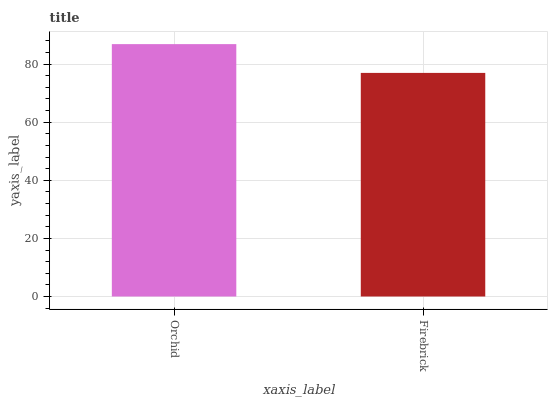Is Firebrick the minimum?
Answer yes or no. Yes. Is Orchid the maximum?
Answer yes or no. Yes. Is Firebrick the maximum?
Answer yes or no. No. Is Orchid greater than Firebrick?
Answer yes or no. Yes. Is Firebrick less than Orchid?
Answer yes or no. Yes. Is Firebrick greater than Orchid?
Answer yes or no. No. Is Orchid less than Firebrick?
Answer yes or no. No. Is Orchid the high median?
Answer yes or no. Yes. Is Firebrick the low median?
Answer yes or no. Yes. Is Firebrick the high median?
Answer yes or no. No. Is Orchid the low median?
Answer yes or no. No. 